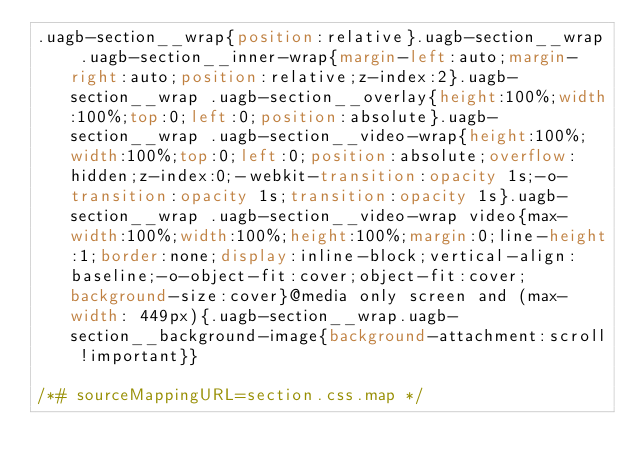Convert code to text. <code><loc_0><loc_0><loc_500><loc_500><_CSS_>.uagb-section__wrap{position:relative}.uagb-section__wrap .uagb-section__inner-wrap{margin-left:auto;margin-right:auto;position:relative;z-index:2}.uagb-section__wrap .uagb-section__overlay{height:100%;width:100%;top:0;left:0;position:absolute}.uagb-section__wrap .uagb-section__video-wrap{height:100%;width:100%;top:0;left:0;position:absolute;overflow:hidden;z-index:0;-webkit-transition:opacity 1s;-o-transition:opacity 1s;transition:opacity 1s}.uagb-section__wrap .uagb-section__video-wrap video{max-width:100%;width:100%;height:100%;margin:0;line-height:1;border:none;display:inline-block;vertical-align:baseline;-o-object-fit:cover;object-fit:cover;background-size:cover}@media only screen and (max-width: 449px){.uagb-section__wrap.uagb-section__background-image{background-attachment:scroll !important}}

/*# sourceMappingURL=section.css.map */</code> 